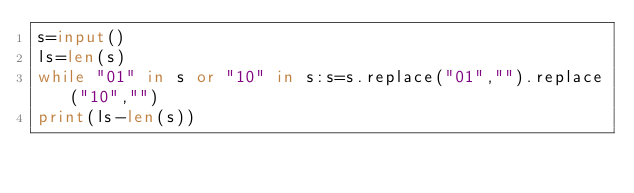Convert code to text. <code><loc_0><loc_0><loc_500><loc_500><_Python_>s=input()
ls=len(s)
while "01" in s or "10" in s:s=s.replace("01","").replace("10","")
print(ls-len(s))</code> 